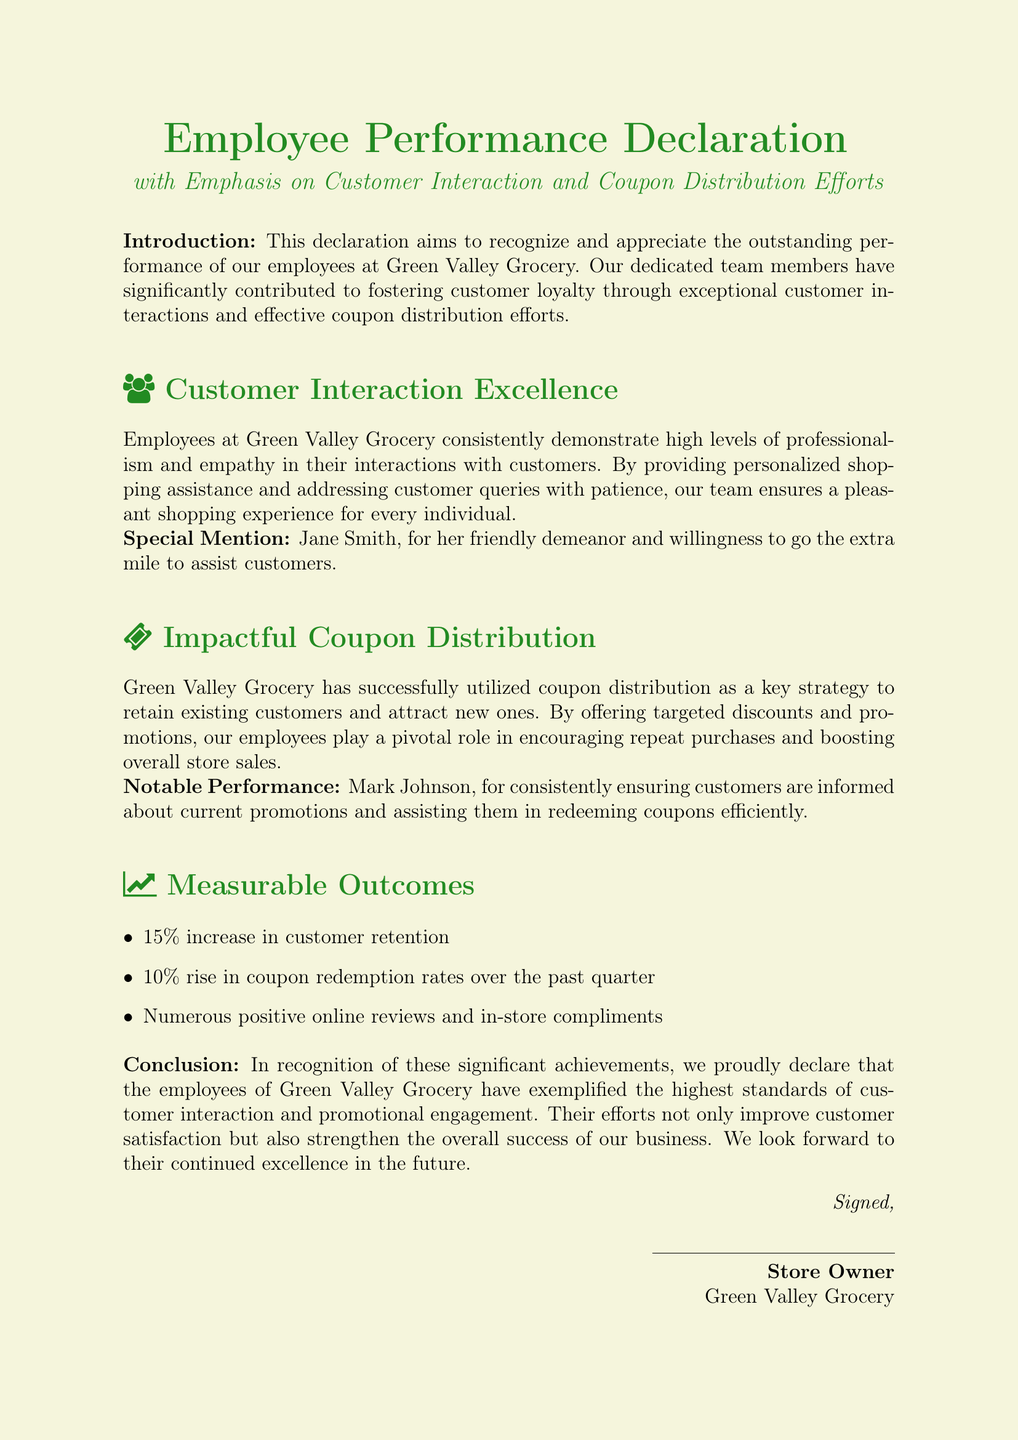What is the title of the document? The title of the document is displayed prominently at the top, highlighting the subject of the declaration.
Answer: Employee Performance Declaration Who is specifically mentioned for Customer Interaction Excellence? This person's name is included in the special mention section regarding customer interactions.
Answer: Jane Smith What was the percentage increase in customer retention? The increase is clearly stated in the measurable outcomes section of the document.
Answer: 15% Who received notable performance recognition for coupon distribution? This individual is specifically mentioned for their efforts in ensuring customers are aware of promotions.
Answer: Mark Johnson What type of discounts were used to foster customer loyalty? This refers to the strategy employed by the grocery store as outlined in the document.
Answer: Targeted discounts How much did the coupon redemption rates rise over the past quarter? The document specifies this change in a measurable outcome.
Answer: 10% What is emphasized in the title of the document? The title mentions the main aspects that the declaration focuses on.
Answer: Customer Interaction and Coupon Distribution Efforts What kind of interactions do employees at Green Valley Grocery aim to provide? This describes the nature of employee-customer interactions as noted in the introduction.
Answer: Pleasant shopping experience 